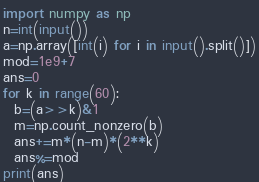<code> <loc_0><loc_0><loc_500><loc_500><_Python_>import numpy as np
n=int(input())
a=np.array([int(i) for i in input().split()])
mod=1e9+7
ans=0
for k in range(60):
  b=(a>>k)&1
  m=np.count_nonzero(b)
  ans+=m*(n-m)*(2**k)
  ans%=mod
print(ans)</code> 